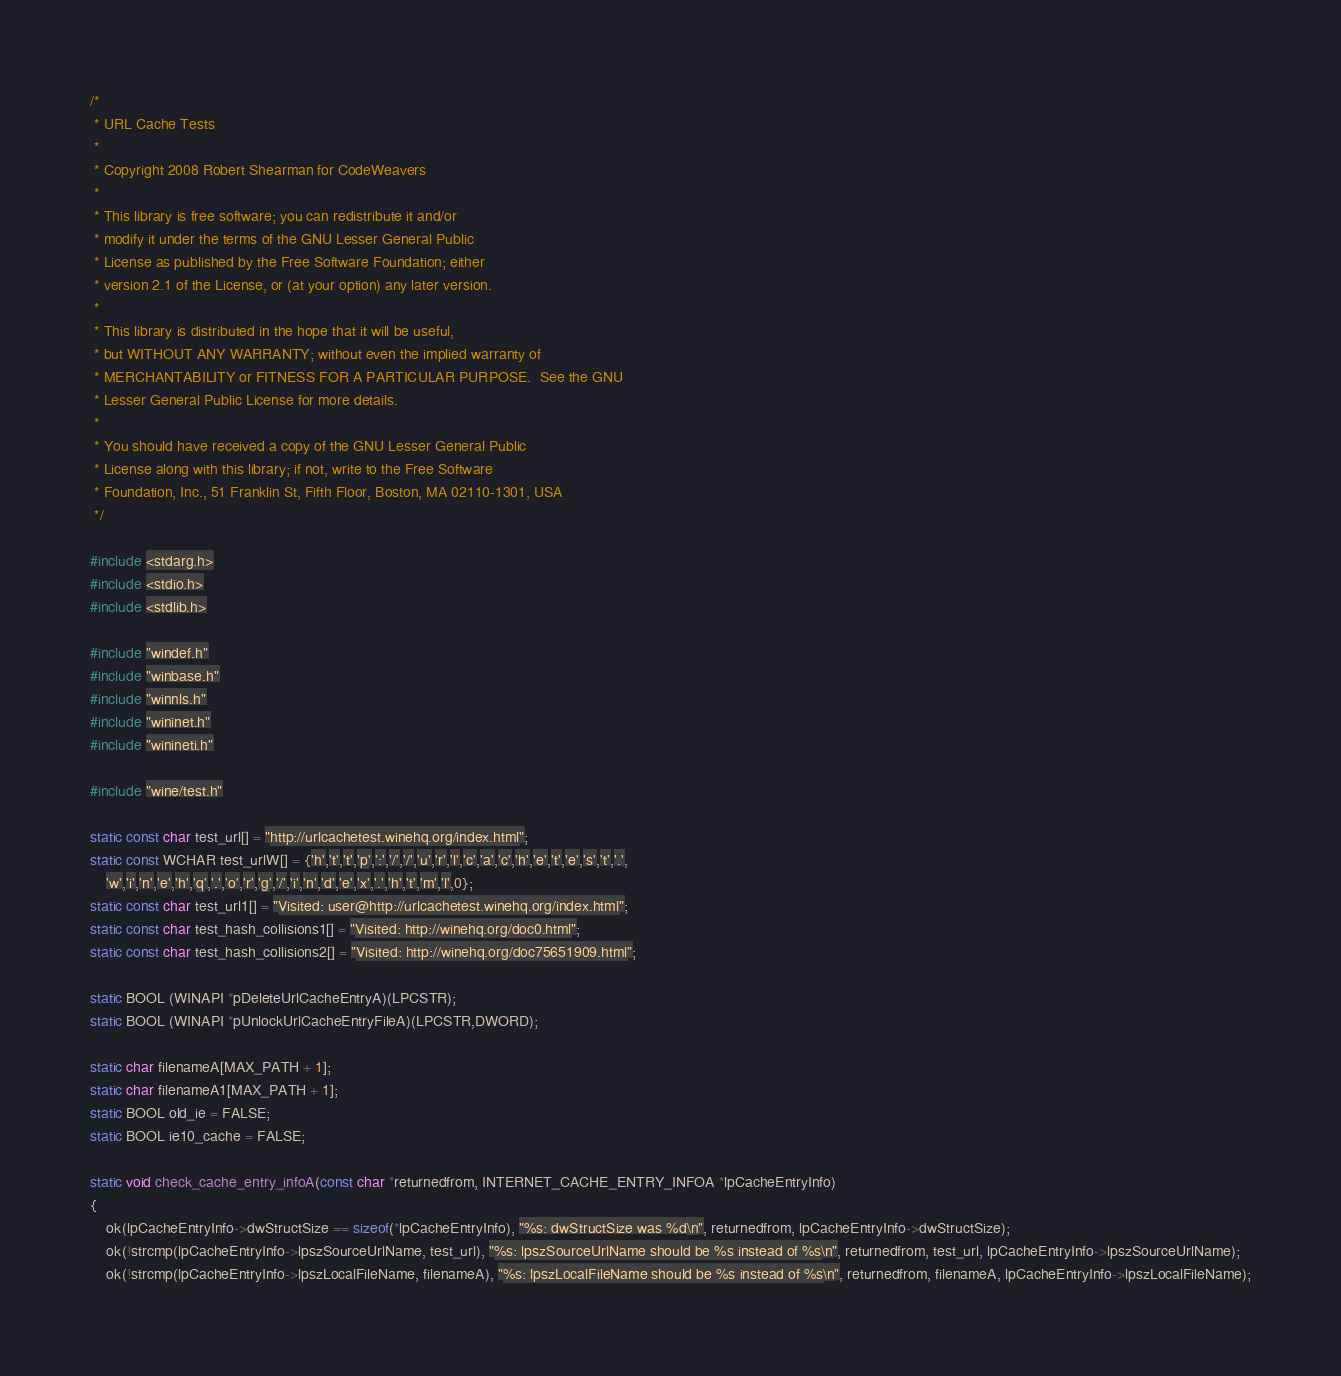<code> <loc_0><loc_0><loc_500><loc_500><_C_>/*
 * URL Cache Tests
 *
 * Copyright 2008 Robert Shearman for CodeWeavers
 *
 * This library is free software; you can redistribute it and/or
 * modify it under the terms of the GNU Lesser General Public
 * License as published by the Free Software Foundation; either
 * version 2.1 of the License, or (at your option) any later version.
 *
 * This library is distributed in the hope that it will be useful,
 * but WITHOUT ANY WARRANTY; without even the implied warranty of
 * MERCHANTABILITY or FITNESS FOR A PARTICULAR PURPOSE.  See the GNU
 * Lesser General Public License for more details.
 *
 * You should have received a copy of the GNU Lesser General Public
 * License along with this library; if not, write to the Free Software
 * Foundation, Inc., 51 Franklin St, Fifth Floor, Boston, MA 02110-1301, USA
 */

#include <stdarg.h>
#include <stdio.h>
#include <stdlib.h>

#include "windef.h"
#include "winbase.h"
#include "winnls.h"
#include "wininet.h"
#include "winineti.h"

#include "wine/test.h"

static const char test_url[] = "http://urlcachetest.winehq.org/index.html";
static const WCHAR test_urlW[] = {'h','t','t','p',':','/','/','u','r','l','c','a','c','h','e','t','e','s','t','.',
    'w','i','n','e','h','q','.','o','r','g','/','i','n','d','e','x','.','h','t','m','l',0};
static const char test_url1[] = "Visited: user@http://urlcachetest.winehq.org/index.html";
static const char test_hash_collisions1[] = "Visited: http://winehq.org/doc0.html";
static const char test_hash_collisions2[] = "Visited: http://winehq.org/doc75651909.html";

static BOOL (WINAPI *pDeleteUrlCacheEntryA)(LPCSTR);
static BOOL (WINAPI *pUnlockUrlCacheEntryFileA)(LPCSTR,DWORD);

static char filenameA[MAX_PATH + 1];
static char filenameA1[MAX_PATH + 1];
static BOOL old_ie = FALSE;
static BOOL ie10_cache = FALSE;

static void check_cache_entry_infoA(const char *returnedfrom, INTERNET_CACHE_ENTRY_INFOA *lpCacheEntryInfo)
{
    ok(lpCacheEntryInfo->dwStructSize == sizeof(*lpCacheEntryInfo), "%s: dwStructSize was %d\n", returnedfrom, lpCacheEntryInfo->dwStructSize);
    ok(!strcmp(lpCacheEntryInfo->lpszSourceUrlName, test_url), "%s: lpszSourceUrlName should be %s instead of %s\n", returnedfrom, test_url, lpCacheEntryInfo->lpszSourceUrlName);
    ok(!strcmp(lpCacheEntryInfo->lpszLocalFileName, filenameA), "%s: lpszLocalFileName should be %s instead of %s\n", returnedfrom, filenameA, lpCacheEntryInfo->lpszLocalFileName);</code> 